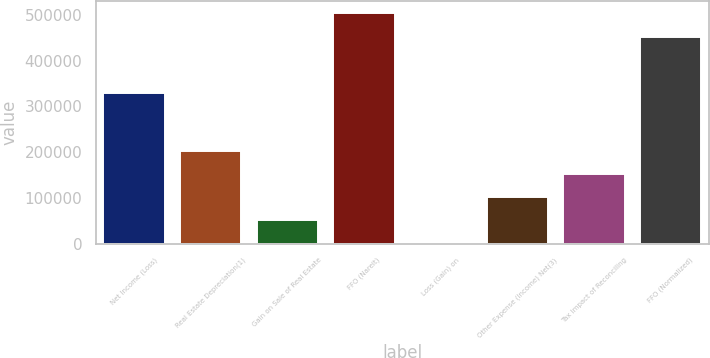<chart> <loc_0><loc_0><loc_500><loc_500><bar_chart><fcel>Net Income (Loss)<fcel>Real Estate Depreciation(1)<fcel>Gain on Sale of Real Estate<fcel>FFO (Nareit)<fcel>Loss (Gain) on<fcel>Other Expense (Income) Net(3)<fcel>Tax Impact of Reconciling<fcel>FFO (Normalized)<nl><fcel>328746<fcel>202483<fcel>51419.4<fcel>504609<fcel>1065<fcel>101774<fcel>152128<fcel>451188<nl></chart> 